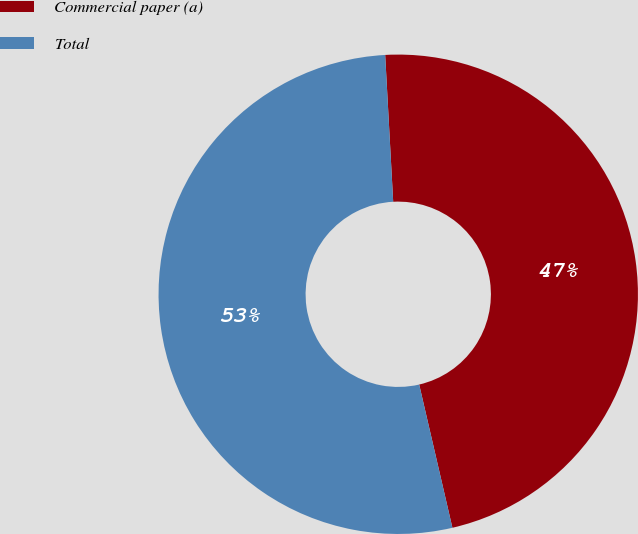Convert chart. <chart><loc_0><loc_0><loc_500><loc_500><pie_chart><fcel>Commercial paper (a)<fcel>Total<nl><fcel>47.24%<fcel>52.76%<nl></chart> 